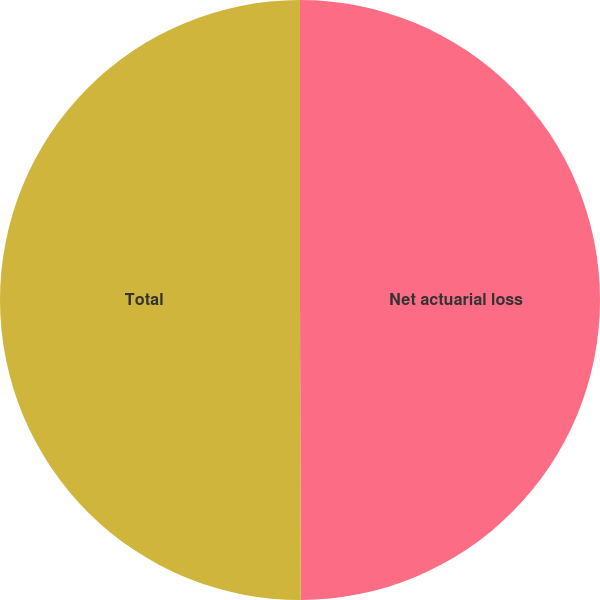<chart> <loc_0><loc_0><loc_500><loc_500><pie_chart><fcel>Net actuarial loss<fcel>Total<nl><fcel>49.96%<fcel>50.04%<nl></chart> 